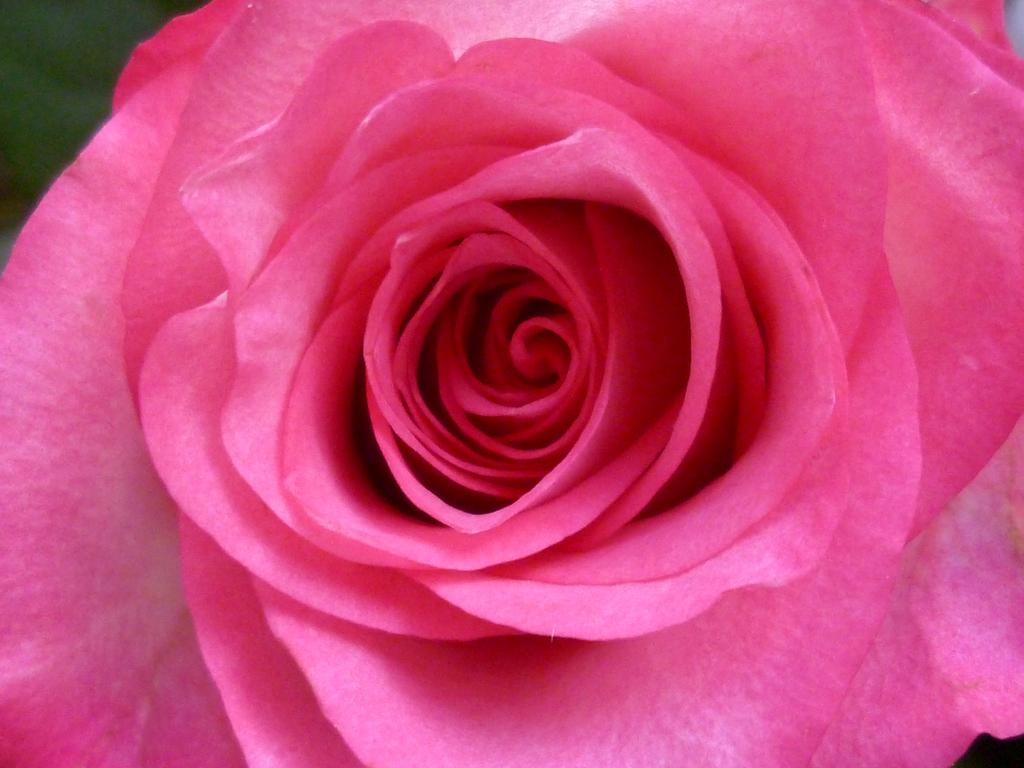What type of flower is in the foreground of the image? There is a rose flower in the foreground of the image. What organization is offering the rose flower in the image? There is no organization present in the image, and the rose flower is not being offered by anyone. 